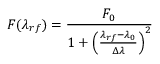<formula> <loc_0><loc_0><loc_500><loc_500>F ( \lambda _ { r f } ) = \frac { F _ { 0 } } { 1 + \left ( \frac { \lambda _ { r f } - \lambda _ { 0 } } { \Delta \lambda } \right ) ^ { 2 } }</formula> 